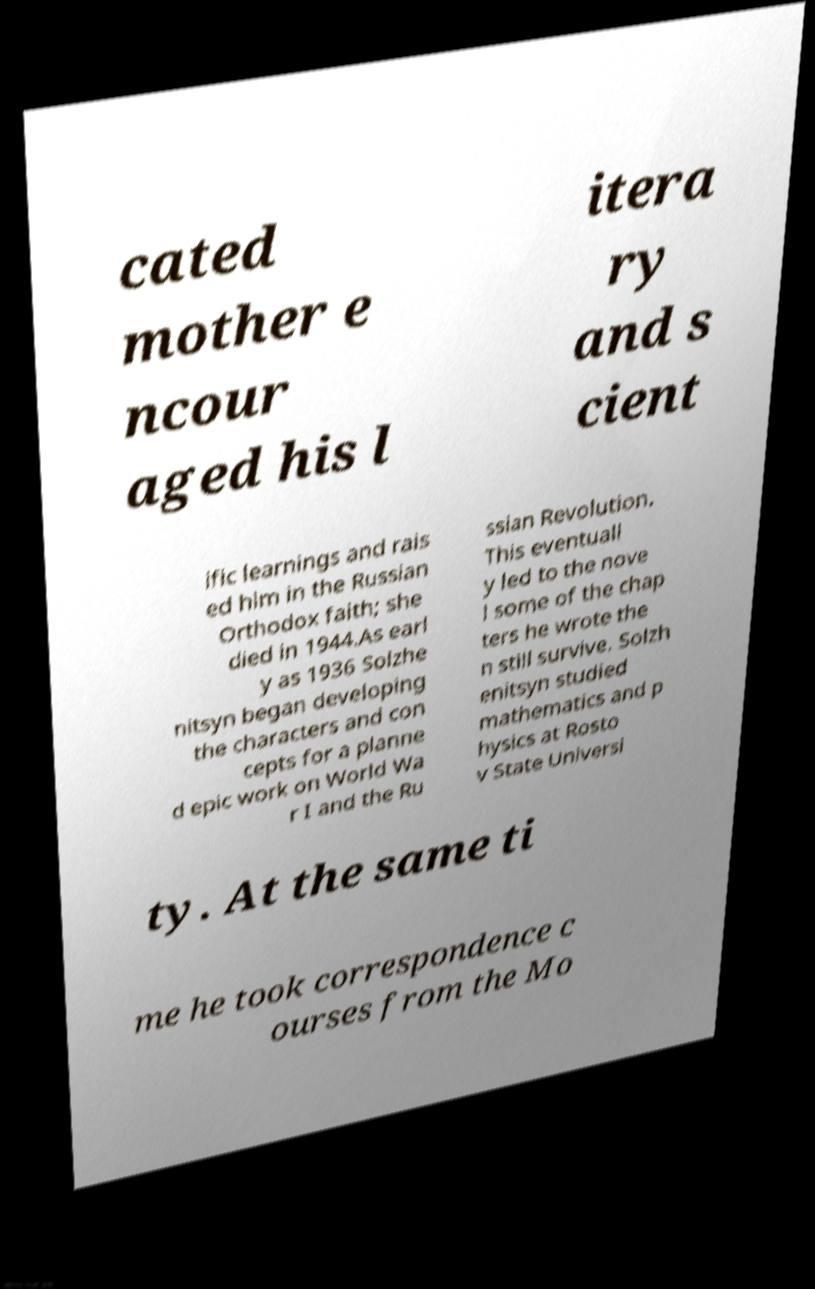I need the written content from this picture converted into text. Can you do that? cated mother e ncour aged his l itera ry and s cient ific learnings and rais ed him in the Russian Orthodox faith; she died in 1944.As earl y as 1936 Solzhe nitsyn began developing the characters and con cepts for a planne d epic work on World Wa r I and the Ru ssian Revolution. This eventuall y led to the nove l some of the chap ters he wrote the n still survive. Solzh enitsyn studied mathematics and p hysics at Rosto v State Universi ty. At the same ti me he took correspondence c ourses from the Mo 